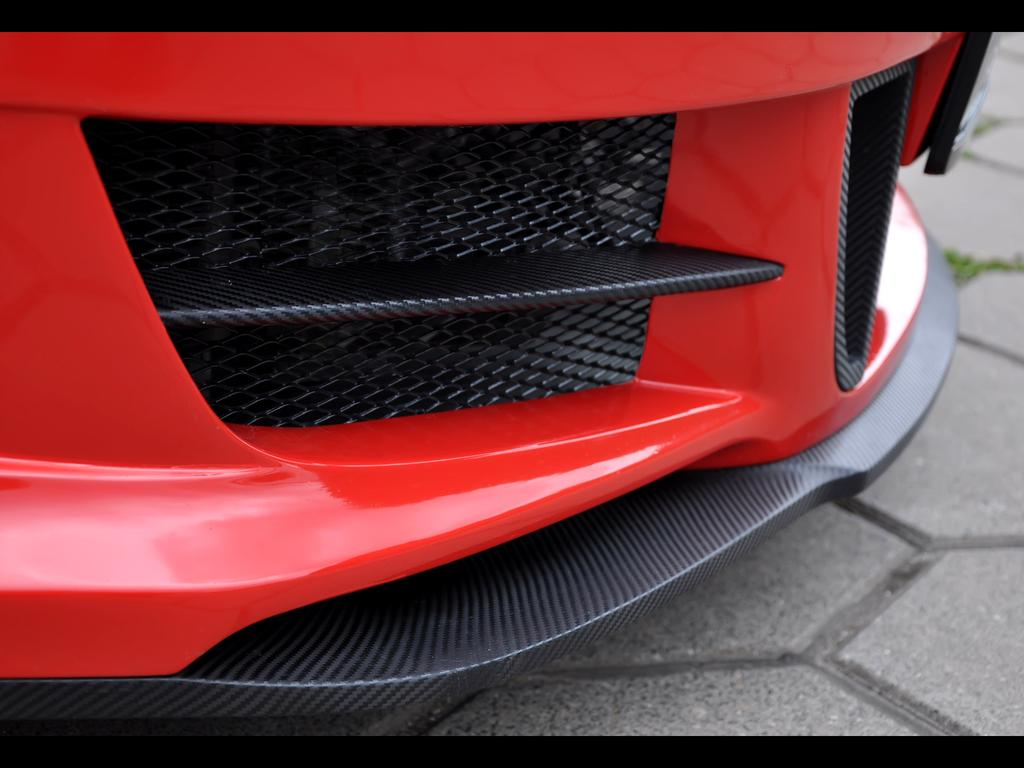What is the main subject in the front of the image? There is an object in the front of the image. Can you describe the colors of the object? The object is red and black in color. What type of vegetation is present on the right side of the image? There is grass on the ground on the right side of the image. How many sisters are sitting on the object in the image? There are no sisters present in the image, and the object does not appear to be a place for sitting. 